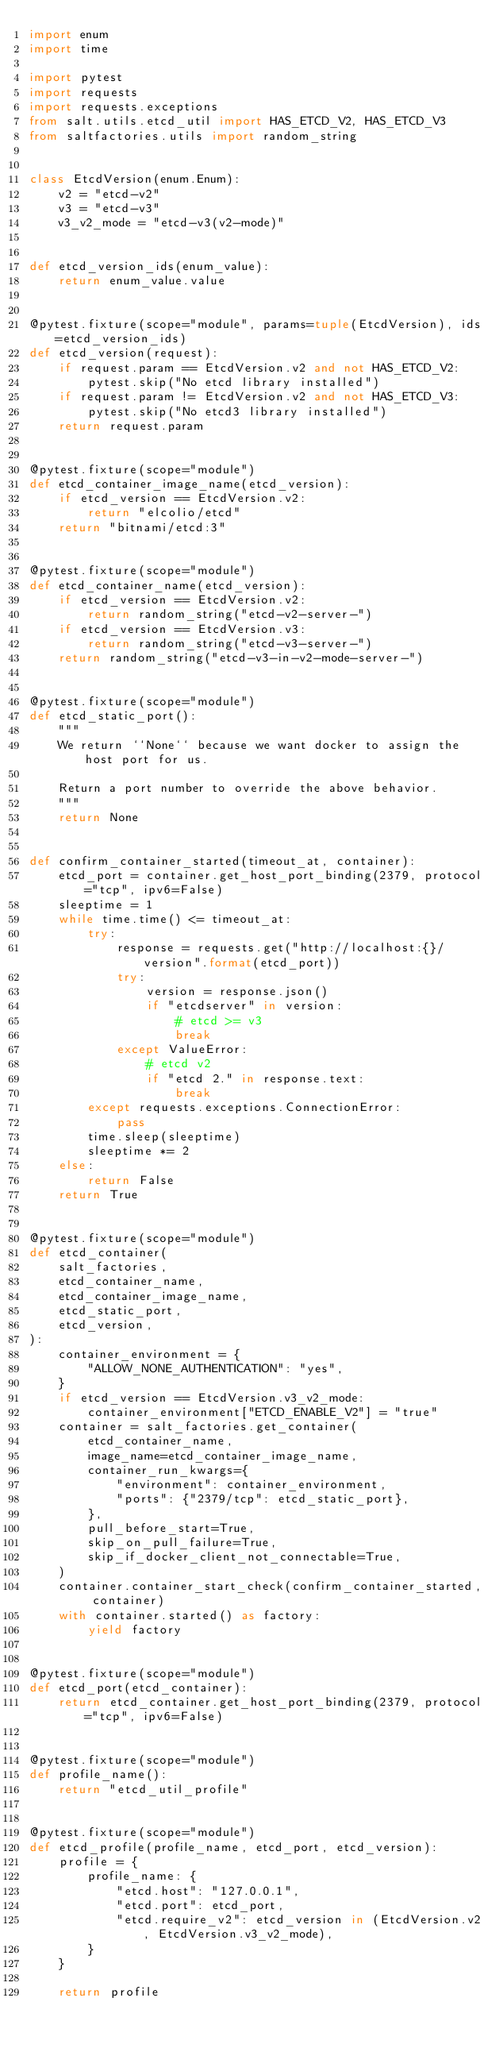Convert code to text. <code><loc_0><loc_0><loc_500><loc_500><_Python_>import enum
import time

import pytest
import requests
import requests.exceptions
from salt.utils.etcd_util import HAS_ETCD_V2, HAS_ETCD_V3
from saltfactories.utils import random_string


class EtcdVersion(enum.Enum):
    v2 = "etcd-v2"
    v3 = "etcd-v3"
    v3_v2_mode = "etcd-v3(v2-mode)"


def etcd_version_ids(enum_value):
    return enum_value.value


@pytest.fixture(scope="module", params=tuple(EtcdVersion), ids=etcd_version_ids)
def etcd_version(request):
    if request.param == EtcdVersion.v2 and not HAS_ETCD_V2:
        pytest.skip("No etcd library installed")
    if request.param != EtcdVersion.v2 and not HAS_ETCD_V3:
        pytest.skip("No etcd3 library installed")
    return request.param


@pytest.fixture(scope="module")
def etcd_container_image_name(etcd_version):
    if etcd_version == EtcdVersion.v2:
        return "elcolio/etcd"
    return "bitnami/etcd:3"


@pytest.fixture(scope="module")
def etcd_container_name(etcd_version):
    if etcd_version == EtcdVersion.v2:
        return random_string("etcd-v2-server-")
    if etcd_version == EtcdVersion.v3:
        return random_string("etcd-v3-server-")
    return random_string("etcd-v3-in-v2-mode-server-")


@pytest.fixture(scope="module")
def etcd_static_port():
    """
    We return ``None`` because we want docker to assign the host port for us.

    Return a port number to override the above behavior.
    """
    return None


def confirm_container_started(timeout_at, container):
    etcd_port = container.get_host_port_binding(2379, protocol="tcp", ipv6=False)
    sleeptime = 1
    while time.time() <= timeout_at:
        try:
            response = requests.get("http://localhost:{}/version".format(etcd_port))
            try:
                version = response.json()
                if "etcdserver" in version:
                    # etcd >= v3
                    break
            except ValueError:
                # etcd v2
                if "etcd 2." in response.text:
                    break
        except requests.exceptions.ConnectionError:
            pass
        time.sleep(sleeptime)
        sleeptime *= 2
    else:
        return False
    return True


@pytest.fixture(scope="module")
def etcd_container(
    salt_factories,
    etcd_container_name,
    etcd_container_image_name,
    etcd_static_port,
    etcd_version,
):
    container_environment = {
        "ALLOW_NONE_AUTHENTICATION": "yes",
    }
    if etcd_version == EtcdVersion.v3_v2_mode:
        container_environment["ETCD_ENABLE_V2"] = "true"
    container = salt_factories.get_container(
        etcd_container_name,
        image_name=etcd_container_image_name,
        container_run_kwargs={
            "environment": container_environment,
            "ports": {"2379/tcp": etcd_static_port},
        },
        pull_before_start=True,
        skip_on_pull_failure=True,
        skip_if_docker_client_not_connectable=True,
    )
    container.container_start_check(confirm_container_started, container)
    with container.started() as factory:
        yield factory


@pytest.fixture(scope="module")
def etcd_port(etcd_container):
    return etcd_container.get_host_port_binding(2379, protocol="tcp", ipv6=False)


@pytest.fixture(scope="module")
def profile_name():
    return "etcd_util_profile"


@pytest.fixture(scope="module")
def etcd_profile(profile_name, etcd_port, etcd_version):
    profile = {
        profile_name: {
            "etcd.host": "127.0.0.1",
            "etcd.port": etcd_port,
            "etcd.require_v2": etcd_version in (EtcdVersion.v2, EtcdVersion.v3_v2_mode),
        }
    }

    return profile
</code> 